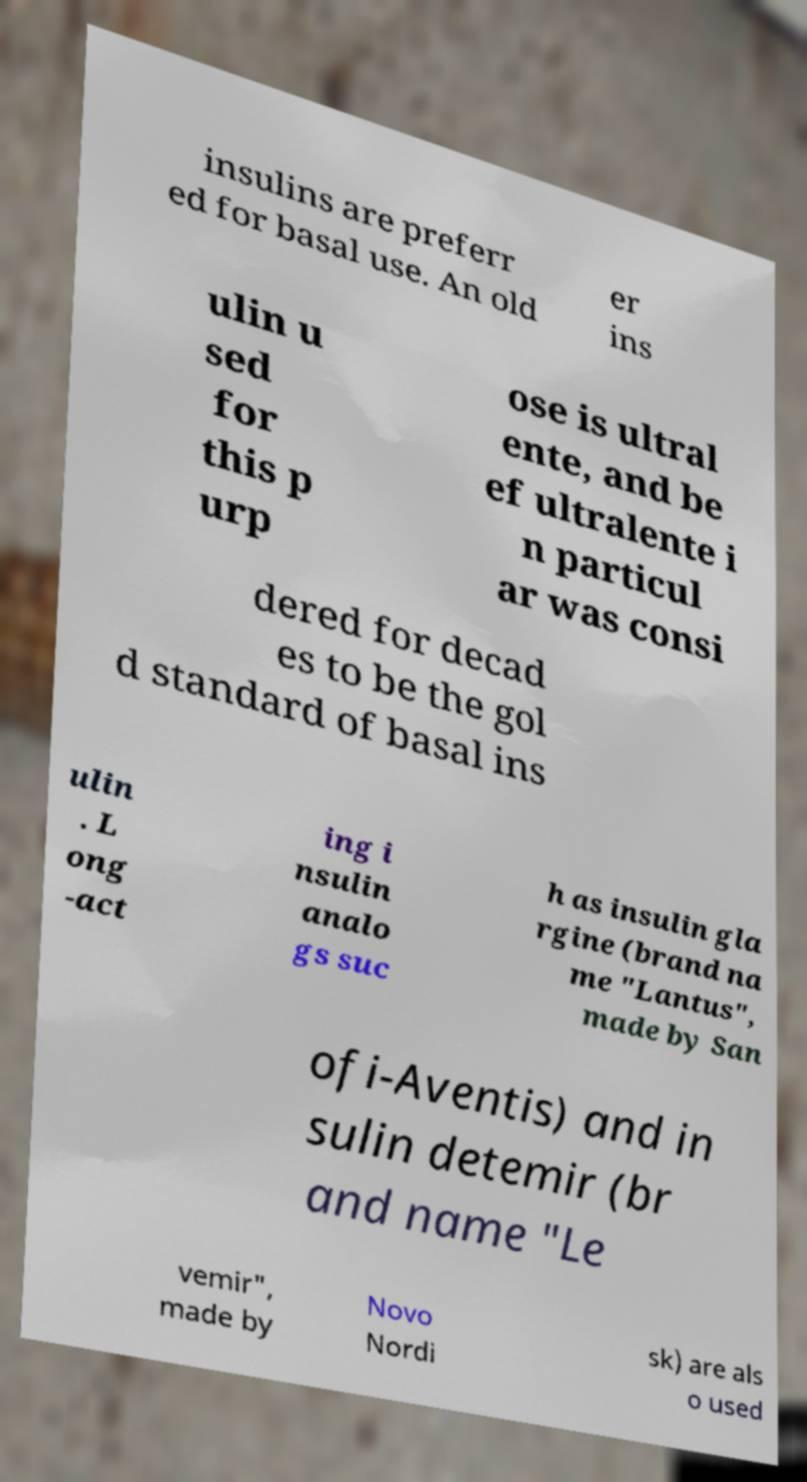What messages or text are displayed in this image? I need them in a readable, typed format. insulins are preferr ed for basal use. An old er ins ulin u sed for this p urp ose is ultral ente, and be ef ultralente i n particul ar was consi dered for decad es to be the gol d standard of basal ins ulin . L ong -act ing i nsulin analo gs suc h as insulin gla rgine (brand na me "Lantus", made by San ofi-Aventis) and in sulin detemir (br and name "Le vemir", made by Novo Nordi sk) are als o used 